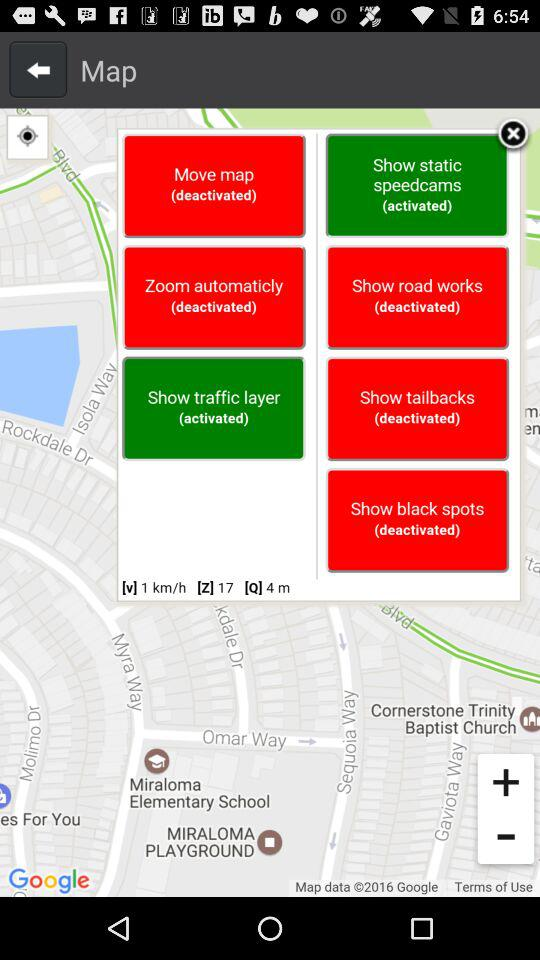What is the speed of the vehicle?
Answer the question using a single word or phrase. 1 km/h 